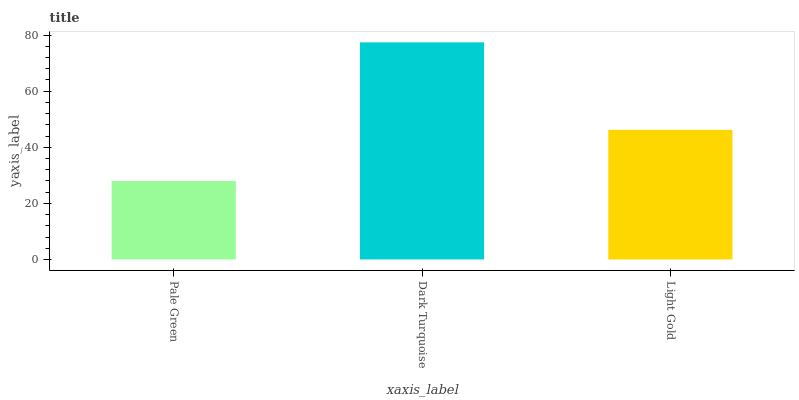Is Pale Green the minimum?
Answer yes or no. Yes. Is Dark Turquoise the maximum?
Answer yes or no. Yes. Is Light Gold the minimum?
Answer yes or no. No. Is Light Gold the maximum?
Answer yes or no. No. Is Dark Turquoise greater than Light Gold?
Answer yes or no. Yes. Is Light Gold less than Dark Turquoise?
Answer yes or no. Yes. Is Light Gold greater than Dark Turquoise?
Answer yes or no. No. Is Dark Turquoise less than Light Gold?
Answer yes or no. No. Is Light Gold the high median?
Answer yes or no. Yes. Is Light Gold the low median?
Answer yes or no. Yes. Is Dark Turquoise the high median?
Answer yes or no. No. Is Pale Green the low median?
Answer yes or no. No. 